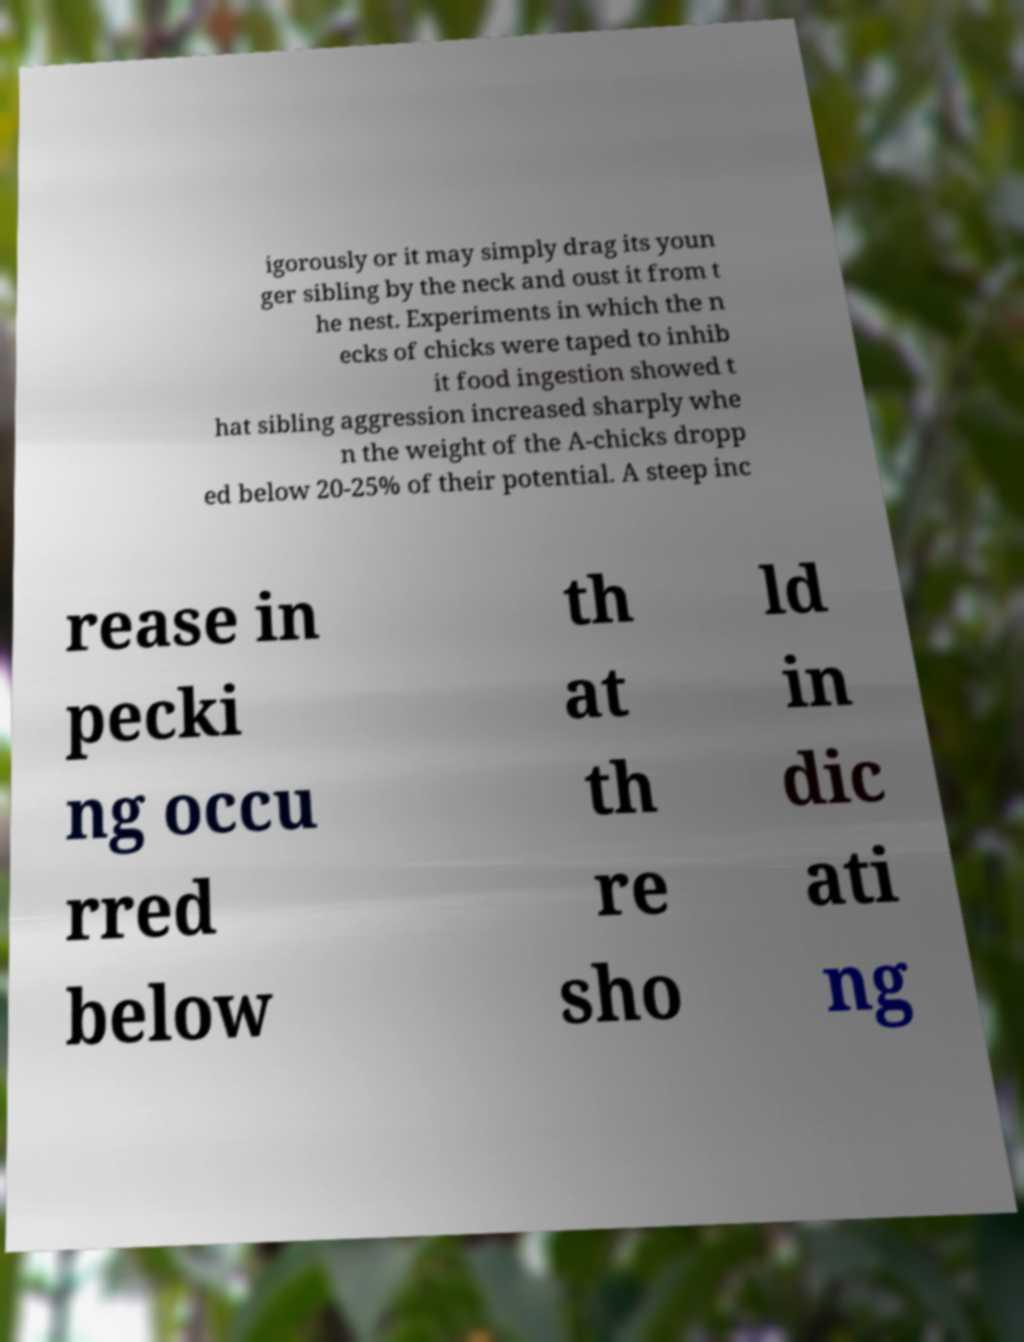Could you assist in decoding the text presented in this image and type it out clearly? igorously or it may simply drag its youn ger sibling by the neck and oust it from t he nest. Experiments in which the n ecks of chicks were taped to inhib it food ingestion showed t hat sibling aggression increased sharply whe n the weight of the A-chicks dropp ed below 20-25% of their potential. A steep inc rease in pecki ng occu rred below th at th re sho ld in dic ati ng 